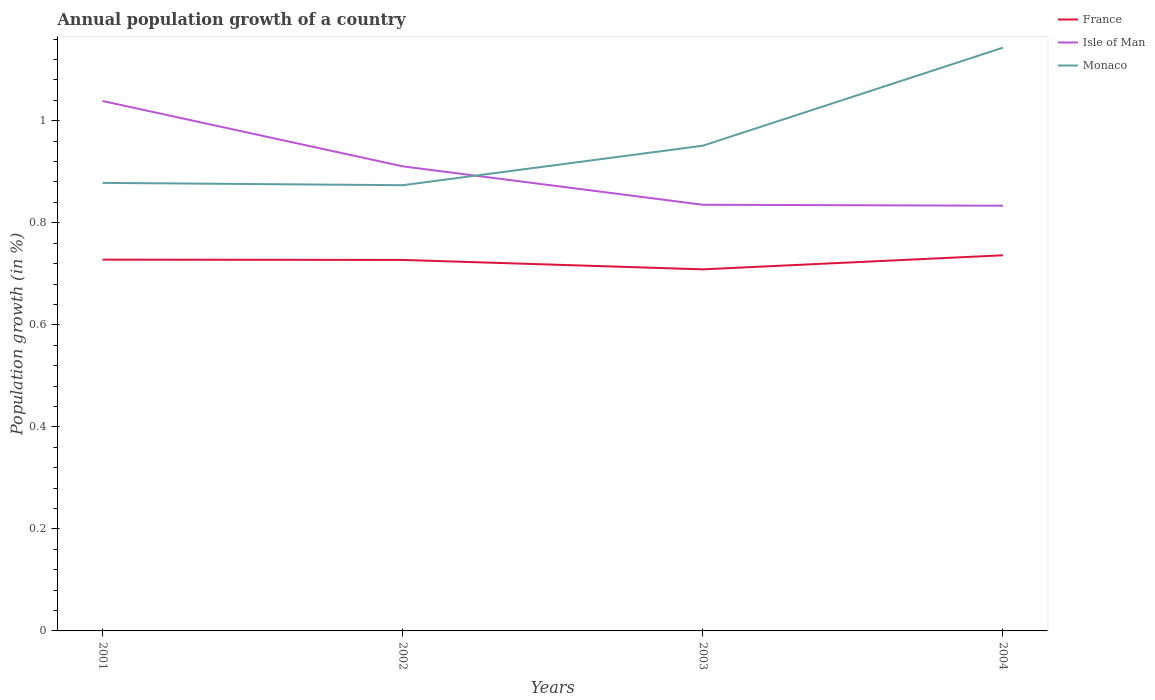Is the number of lines equal to the number of legend labels?
Provide a short and direct response. Yes. Across all years, what is the maximum annual population growth in Isle of Man?
Offer a very short reply. 0.83. In which year was the annual population growth in Isle of Man maximum?
Ensure brevity in your answer.  2004. What is the total annual population growth in Monaco in the graph?
Offer a terse response. 0. What is the difference between the highest and the second highest annual population growth in Isle of Man?
Give a very brief answer. 0.21. What is the difference between the highest and the lowest annual population growth in Monaco?
Offer a terse response. 1. Is the annual population growth in France strictly greater than the annual population growth in Isle of Man over the years?
Provide a succinct answer. Yes. Are the values on the major ticks of Y-axis written in scientific E-notation?
Offer a very short reply. No. Does the graph contain any zero values?
Make the answer very short. No. Where does the legend appear in the graph?
Provide a succinct answer. Top right. How many legend labels are there?
Provide a short and direct response. 3. How are the legend labels stacked?
Your answer should be compact. Vertical. What is the title of the graph?
Give a very brief answer. Annual population growth of a country. What is the label or title of the X-axis?
Make the answer very short. Years. What is the label or title of the Y-axis?
Keep it short and to the point. Population growth (in %). What is the Population growth (in %) in France in 2001?
Provide a short and direct response. 0.73. What is the Population growth (in %) of Isle of Man in 2001?
Give a very brief answer. 1.04. What is the Population growth (in %) of Monaco in 2001?
Provide a short and direct response. 0.88. What is the Population growth (in %) in France in 2002?
Provide a succinct answer. 0.73. What is the Population growth (in %) in Isle of Man in 2002?
Your response must be concise. 0.91. What is the Population growth (in %) of Monaco in 2002?
Provide a succinct answer. 0.87. What is the Population growth (in %) of France in 2003?
Ensure brevity in your answer.  0.71. What is the Population growth (in %) of Isle of Man in 2003?
Your response must be concise. 0.84. What is the Population growth (in %) in Monaco in 2003?
Your answer should be very brief. 0.95. What is the Population growth (in %) in France in 2004?
Give a very brief answer. 0.74. What is the Population growth (in %) of Isle of Man in 2004?
Give a very brief answer. 0.83. What is the Population growth (in %) of Monaco in 2004?
Ensure brevity in your answer.  1.14. Across all years, what is the maximum Population growth (in %) in France?
Your response must be concise. 0.74. Across all years, what is the maximum Population growth (in %) of Isle of Man?
Your response must be concise. 1.04. Across all years, what is the maximum Population growth (in %) of Monaco?
Provide a short and direct response. 1.14. Across all years, what is the minimum Population growth (in %) of France?
Make the answer very short. 0.71. Across all years, what is the minimum Population growth (in %) of Isle of Man?
Your response must be concise. 0.83. Across all years, what is the minimum Population growth (in %) in Monaco?
Give a very brief answer. 0.87. What is the total Population growth (in %) in France in the graph?
Your response must be concise. 2.9. What is the total Population growth (in %) of Isle of Man in the graph?
Offer a very short reply. 3.62. What is the total Population growth (in %) of Monaco in the graph?
Keep it short and to the point. 3.85. What is the difference between the Population growth (in %) in France in 2001 and that in 2002?
Provide a succinct answer. 0. What is the difference between the Population growth (in %) in Isle of Man in 2001 and that in 2002?
Ensure brevity in your answer.  0.13. What is the difference between the Population growth (in %) of Monaco in 2001 and that in 2002?
Offer a very short reply. 0. What is the difference between the Population growth (in %) in France in 2001 and that in 2003?
Ensure brevity in your answer.  0.02. What is the difference between the Population growth (in %) in Isle of Man in 2001 and that in 2003?
Your response must be concise. 0.2. What is the difference between the Population growth (in %) of Monaco in 2001 and that in 2003?
Your response must be concise. -0.07. What is the difference between the Population growth (in %) of France in 2001 and that in 2004?
Ensure brevity in your answer.  -0.01. What is the difference between the Population growth (in %) of Isle of Man in 2001 and that in 2004?
Your answer should be compact. 0.21. What is the difference between the Population growth (in %) in Monaco in 2001 and that in 2004?
Provide a succinct answer. -0.27. What is the difference between the Population growth (in %) of France in 2002 and that in 2003?
Your response must be concise. 0.02. What is the difference between the Population growth (in %) of Isle of Man in 2002 and that in 2003?
Your response must be concise. 0.08. What is the difference between the Population growth (in %) of Monaco in 2002 and that in 2003?
Ensure brevity in your answer.  -0.08. What is the difference between the Population growth (in %) in France in 2002 and that in 2004?
Make the answer very short. -0.01. What is the difference between the Population growth (in %) in Isle of Man in 2002 and that in 2004?
Provide a short and direct response. 0.08. What is the difference between the Population growth (in %) of Monaco in 2002 and that in 2004?
Give a very brief answer. -0.27. What is the difference between the Population growth (in %) of France in 2003 and that in 2004?
Give a very brief answer. -0.03. What is the difference between the Population growth (in %) of Isle of Man in 2003 and that in 2004?
Your answer should be compact. 0. What is the difference between the Population growth (in %) in Monaco in 2003 and that in 2004?
Your answer should be very brief. -0.19. What is the difference between the Population growth (in %) of France in 2001 and the Population growth (in %) of Isle of Man in 2002?
Your response must be concise. -0.18. What is the difference between the Population growth (in %) of France in 2001 and the Population growth (in %) of Monaco in 2002?
Ensure brevity in your answer.  -0.15. What is the difference between the Population growth (in %) in Isle of Man in 2001 and the Population growth (in %) in Monaco in 2002?
Keep it short and to the point. 0.17. What is the difference between the Population growth (in %) in France in 2001 and the Population growth (in %) in Isle of Man in 2003?
Offer a very short reply. -0.11. What is the difference between the Population growth (in %) in France in 2001 and the Population growth (in %) in Monaco in 2003?
Your answer should be compact. -0.22. What is the difference between the Population growth (in %) of Isle of Man in 2001 and the Population growth (in %) of Monaco in 2003?
Your answer should be compact. 0.09. What is the difference between the Population growth (in %) of France in 2001 and the Population growth (in %) of Isle of Man in 2004?
Give a very brief answer. -0.11. What is the difference between the Population growth (in %) in France in 2001 and the Population growth (in %) in Monaco in 2004?
Give a very brief answer. -0.42. What is the difference between the Population growth (in %) of Isle of Man in 2001 and the Population growth (in %) of Monaco in 2004?
Make the answer very short. -0.1. What is the difference between the Population growth (in %) of France in 2002 and the Population growth (in %) of Isle of Man in 2003?
Keep it short and to the point. -0.11. What is the difference between the Population growth (in %) in France in 2002 and the Population growth (in %) in Monaco in 2003?
Offer a terse response. -0.22. What is the difference between the Population growth (in %) in Isle of Man in 2002 and the Population growth (in %) in Monaco in 2003?
Give a very brief answer. -0.04. What is the difference between the Population growth (in %) in France in 2002 and the Population growth (in %) in Isle of Man in 2004?
Offer a terse response. -0.11. What is the difference between the Population growth (in %) of France in 2002 and the Population growth (in %) of Monaco in 2004?
Provide a succinct answer. -0.42. What is the difference between the Population growth (in %) in Isle of Man in 2002 and the Population growth (in %) in Monaco in 2004?
Provide a short and direct response. -0.23. What is the difference between the Population growth (in %) in France in 2003 and the Population growth (in %) in Isle of Man in 2004?
Make the answer very short. -0.12. What is the difference between the Population growth (in %) in France in 2003 and the Population growth (in %) in Monaco in 2004?
Your response must be concise. -0.43. What is the difference between the Population growth (in %) in Isle of Man in 2003 and the Population growth (in %) in Monaco in 2004?
Your response must be concise. -0.31. What is the average Population growth (in %) in France per year?
Keep it short and to the point. 0.72. What is the average Population growth (in %) of Isle of Man per year?
Provide a succinct answer. 0.9. What is the average Population growth (in %) in Monaco per year?
Offer a terse response. 0.96. In the year 2001, what is the difference between the Population growth (in %) in France and Population growth (in %) in Isle of Man?
Your response must be concise. -0.31. In the year 2001, what is the difference between the Population growth (in %) of France and Population growth (in %) of Monaco?
Make the answer very short. -0.15. In the year 2001, what is the difference between the Population growth (in %) in Isle of Man and Population growth (in %) in Monaco?
Ensure brevity in your answer.  0.16. In the year 2002, what is the difference between the Population growth (in %) in France and Population growth (in %) in Isle of Man?
Your answer should be very brief. -0.18. In the year 2002, what is the difference between the Population growth (in %) in France and Population growth (in %) in Monaco?
Your answer should be very brief. -0.15. In the year 2002, what is the difference between the Population growth (in %) in Isle of Man and Population growth (in %) in Monaco?
Provide a short and direct response. 0.04. In the year 2003, what is the difference between the Population growth (in %) in France and Population growth (in %) in Isle of Man?
Your response must be concise. -0.13. In the year 2003, what is the difference between the Population growth (in %) of France and Population growth (in %) of Monaco?
Offer a terse response. -0.24. In the year 2003, what is the difference between the Population growth (in %) of Isle of Man and Population growth (in %) of Monaco?
Your answer should be very brief. -0.12. In the year 2004, what is the difference between the Population growth (in %) of France and Population growth (in %) of Isle of Man?
Your response must be concise. -0.1. In the year 2004, what is the difference between the Population growth (in %) of France and Population growth (in %) of Monaco?
Offer a terse response. -0.41. In the year 2004, what is the difference between the Population growth (in %) of Isle of Man and Population growth (in %) of Monaco?
Your response must be concise. -0.31. What is the ratio of the Population growth (in %) in France in 2001 to that in 2002?
Offer a terse response. 1. What is the ratio of the Population growth (in %) of Isle of Man in 2001 to that in 2002?
Give a very brief answer. 1.14. What is the ratio of the Population growth (in %) in France in 2001 to that in 2003?
Offer a very short reply. 1.03. What is the ratio of the Population growth (in %) of Isle of Man in 2001 to that in 2003?
Offer a terse response. 1.24. What is the ratio of the Population growth (in %) of Monaco in 2001 to that in 2003?
Provide a short and direct response. 0.92. What is the ratio of the Population growth (in %) in France in 2001 to that in 2004?
Your answer should be very brief. 0.99. What is the ratio of the Population growth (in %) of Isle of Man in 2001 to that in 2004?
Provide a short and direct response. 1.25. What is the ratio of the Population growth (in %) of Monaco in 2001 to that in 2004?
Your response must be concise. 0.77. What is the ratio of the Population growth (in %) in Isle of Man in 2002 to that in 2003?
Make the answer very short. 1.09. What is the ratio of the Population growth (in %) of Monaco in 2002 to that in 2003?
Your response must be concise. 0.92. What is the ratio of the Population growth (in %) of Isle of Man in 2002 to that in 2004?
Your response must be concise. 1.09. What is the ratio of the Population growth (in %) of Monaco in 2002 to that in 2004?
Ensure brevity in your answer.  0.76. What is the ratio of the Population growth (in %) in France in 2003 to that in 2004?
Your answer should be compact. 0.96. What is the ratio of the Population growth (in %) of Isle of Man in 2003 to that in 2004?
Provide a succinct answer. 1. What is the ratio of the Population growth (in %) in Monaco in 2003 to that in 2004?
Your answer should be very brief. 0.83. What is the difference between the highest and the second highest Population growth (in %) of France?
Offer a very short reply. 0.01. What is the difference between the highest and the second highest Population growth (in %) of Isle of Man?
Ensure brevity in your answer.  0.13. What is the difference between the highest and the second highest Population growth (in %) of Monaco?
Your answer should be compact. 0.19. What is the difference between the highest and the lowest Population growth (in %) of France?
Provide a short and direct response. 0.03. What is the difference between the highest and the lowest Population growth (in %) in Isle of Man?
Provide a short and direct response. 0.21. What is the difference between the highest and the lowest Population growth (in %) of Monaco?
Make the answer very short. 0.27. 